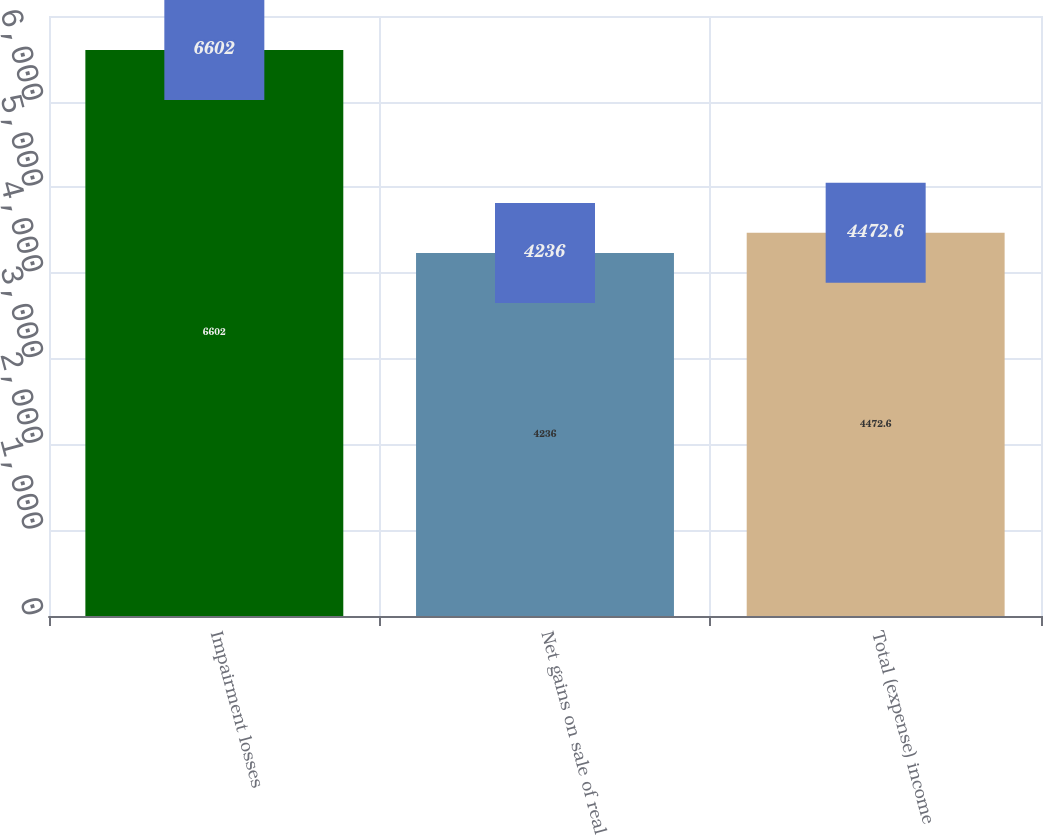Convert chart. <chart><loc_0><loc_0><loc_500><loc_500><bar_chart><fcel>Impairment losses<fcel>Net gains on sale of real<fcel>Total (expense) income<nl><fcel>6602<fcel>4236<fcel>4472.6<nl></chart> 